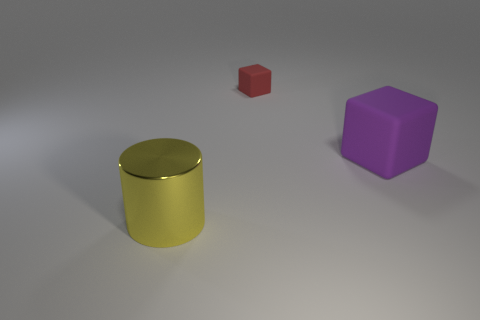Is there anything else that is the same size as the red thing?
Provide a succinct answer. No. The shiny object that is the same size as the purple matte thing is what shape?
Keep it short and to the point. Cylinder. How many other objects are there of the same color as the small thing?
Provide a short and direct response. 0. What is the color of the matte cube that is behind the big purple rubber thing?
Keep it short and to the point. Red. What number of other objects are there of the same material as the purple thing?
Offer a terse response. 1. Is the number of tiny rubber things to the right of the small red cube greater than the number of cubes that are right of the big yellow thing?
Ensure brevity in your answer.  No. There is a small thing; what number of blocks are in front of it?
Offer a very short reply. 1. Are the purple object and the big object that is to the left of the small thing made of the same material?
Your answer should be very brief. No. Is there any other thing that has the same shape as the tiny red object?
Keep it short and to the point. Yes. Do the purple block and the red cube have the same material?
Offer a terse response. Yes. 